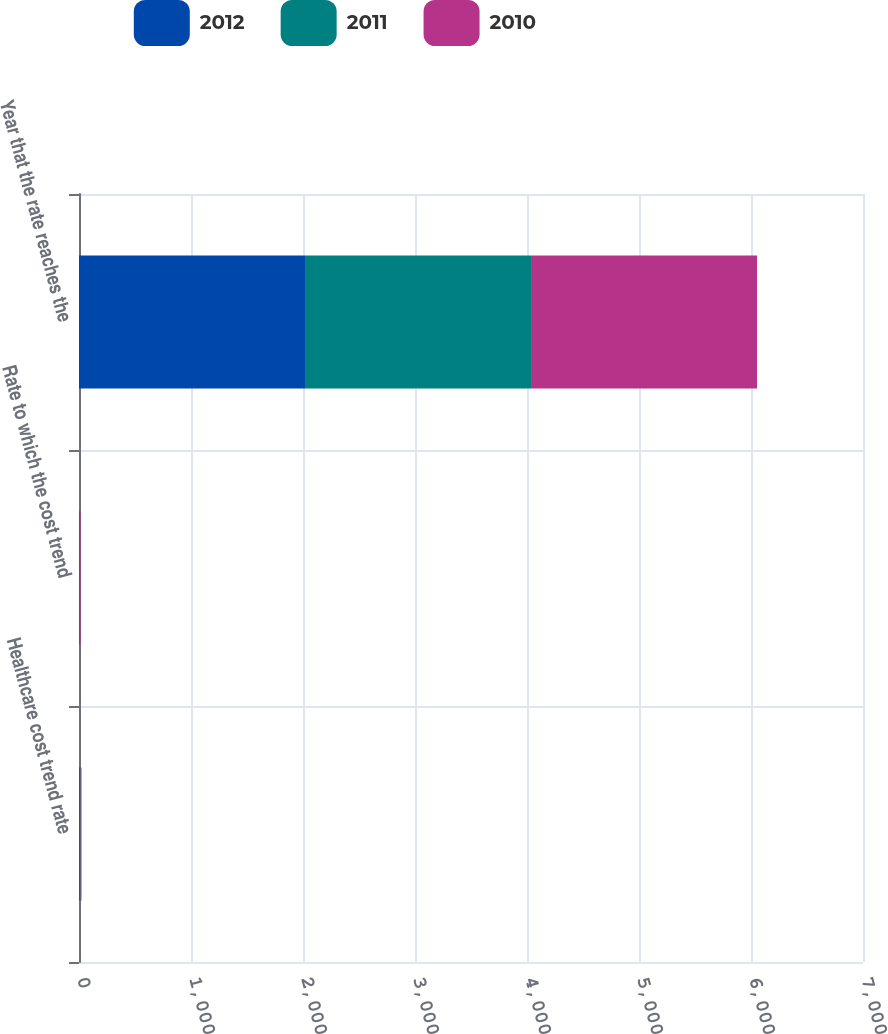Convert chart. <chart><loc_0><loc_0><loc_500><loc_500><stacked_bar_chart><ecel><fcel>Healthcare cost trend rate<fcel>Rate to which the cost trend<fcel>Year that the rate reaches the<nl><fcel>2012<fcel>6.8<fcel>4.5<fcel>2018<nl><fcel>2011<fcel>7.4<fcel>4.5<fcel>2018<nl><fcel>2010<fcel>7.9<fcel>4.5<fcel>2018<nl></chart> 